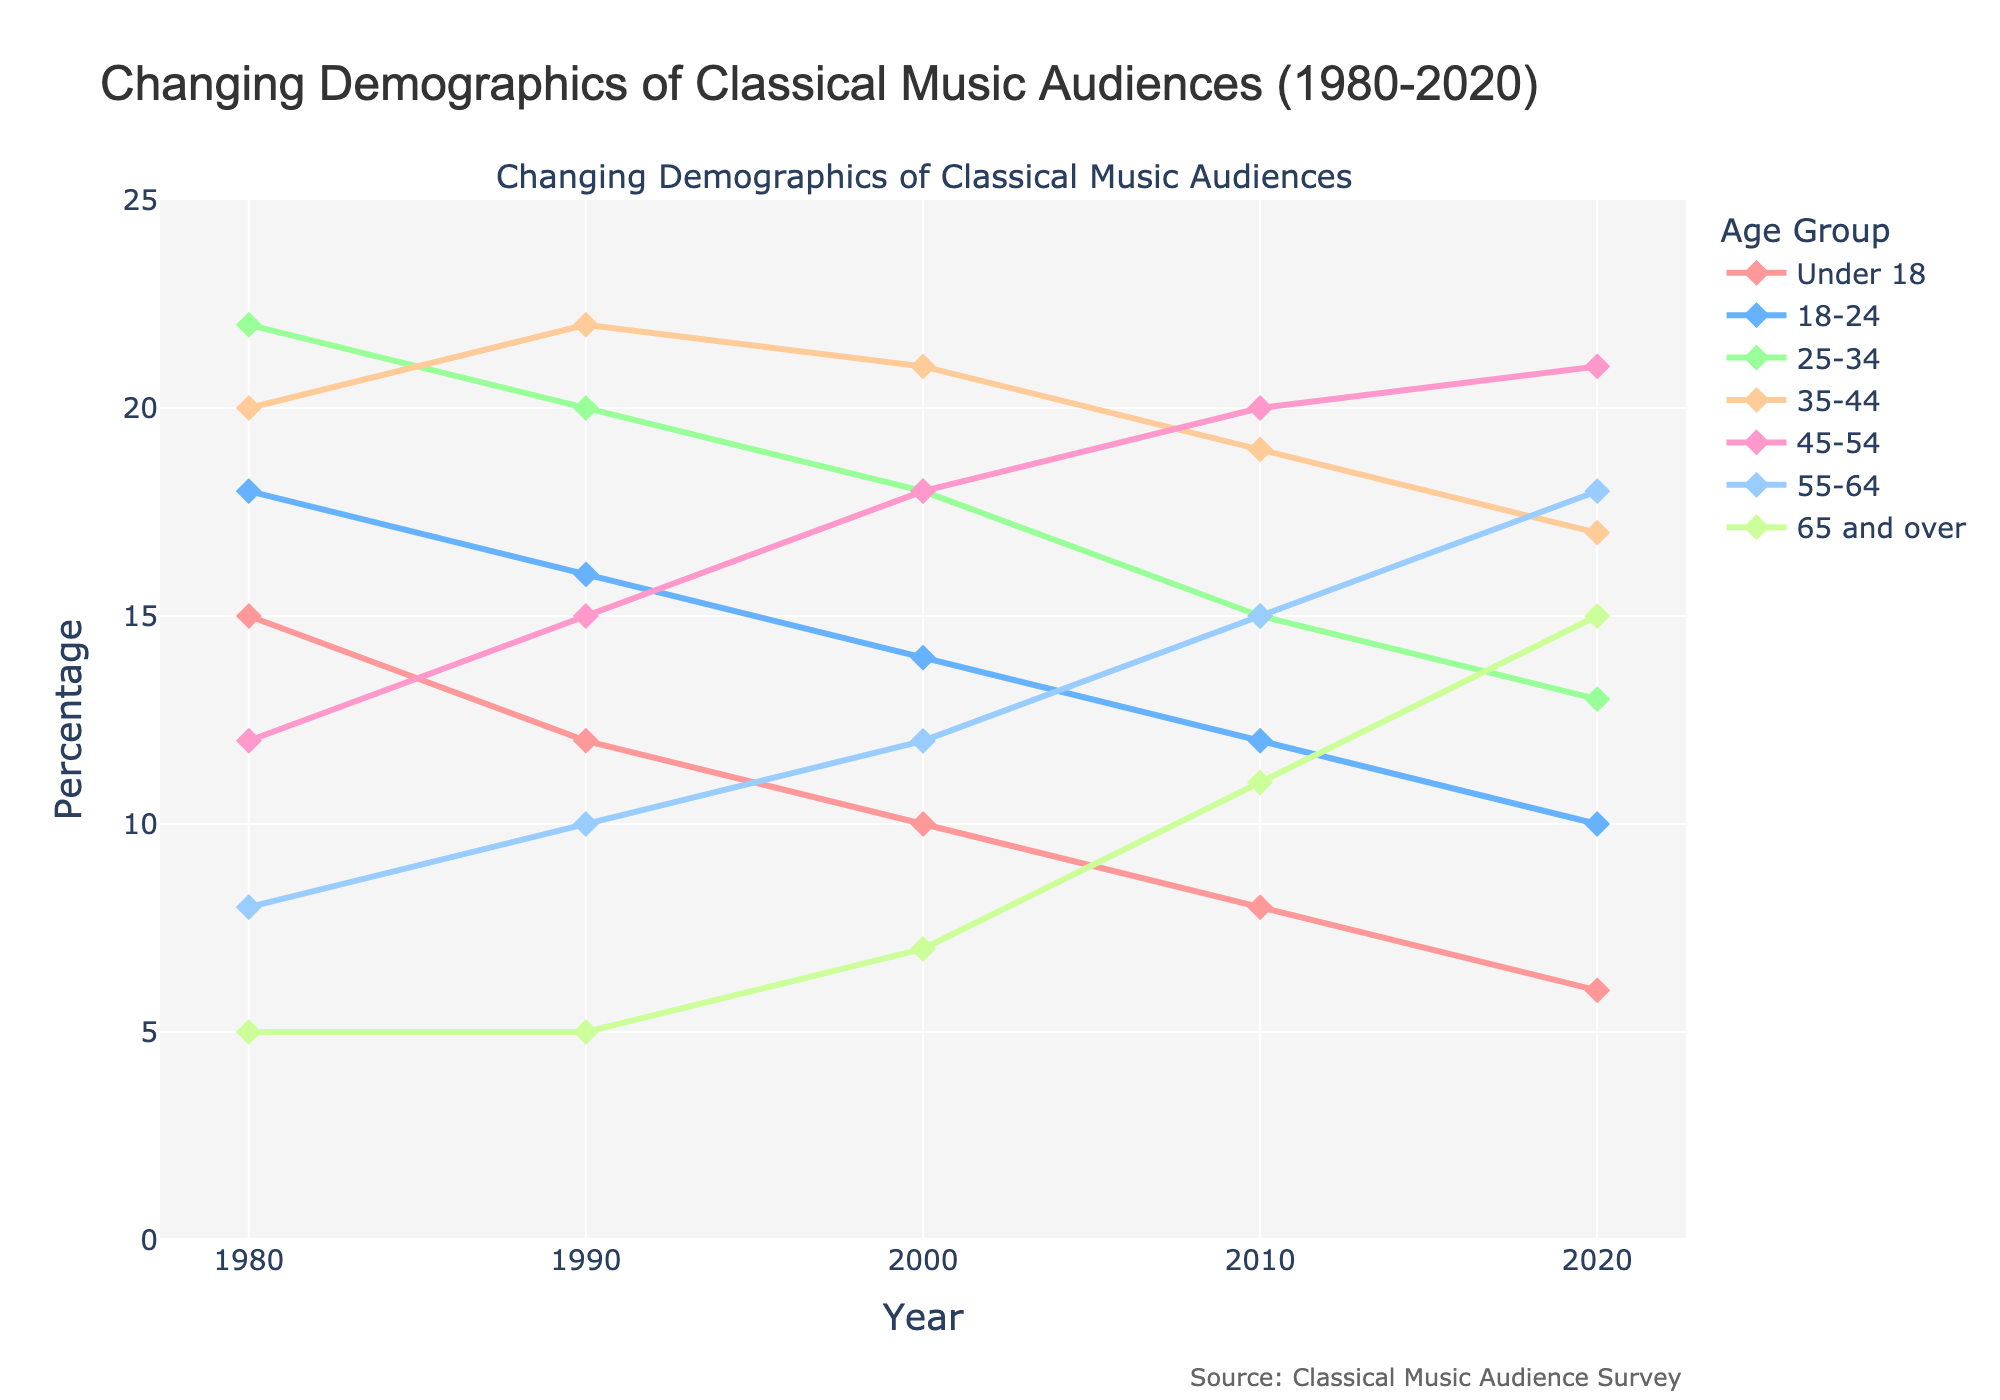What's the most significant trend visible in the age group 'Under 18' from 1980 to 2020? The percentage of audiences under 18 has been decreasing consistently over the years, dropping from 15% in 1980 to 6% in 2020.
Answer: Continuous decrease Which age group had the highest percentage of the classical music audience in 1980? In 1980, the age group 25-34 had the highest percentage at 22%.
Answer: 25-34 Which age group shows an increase in audience percentage over the entire period from 1980 to 2020? The 65 and over age group shows an increase in audience percentage, rising from 5% in 1980 to 15% in 2020.
Answer: 65 and over What is the difference in audience percentage between the 45-54 and 35-44 age groups in 2020? In 2020, the 45-54 age group is at 21% and the 35-44 age group is at 17%. The difference is 21% - 17% = 4%.
Answer: 4% Which age group showed the greatest percentage decrease from 1980 to 2020? The 'Under 18' age group decreased the most, from 15% in 1980 to 6% in 2020, a decrease of 9%.
Answer: Under 18 How did the audience percentage for the 55-64 age group change from 1990 to 2010? The 55-64 age group increased from 10% in 1990 to 15% in 2010, an increase of 5%.
Answer: Increased by 5% Which age groups have crossover points where their percentages were equal during the period from 1980 to 2020? The 35-44 and 45-54 age groups' percentages were equal at around 20% in 2000.
Answer: 35-44 and 45-54 What is the average audience percentage for the age group 18-24 over the years presented? Adding the percentages from 1980, 1990, 2000, 2010, and 2020: 18 + 16 + 14 + 12 + 10 = 70. The average is 70/5 = 14%.
Answer: 14% In which decade did the age group 55-64 see the highest relative growth in percentage? Between 2010 and 2020, the 55-64 age group grew from 15% to 18%, reflecting the highest relative growth compared to previous decades.
Answer: 2010-2020 If you were to compare the overall trends of the age group 'Under 18' and '65 and over', what would you say? 'Under 18' shows a consistent decrease, while '65 and over' shows a consistent increase over the period from 1980 to 2020.
Answer: Under 18 decreasing, 65 and over increasing 